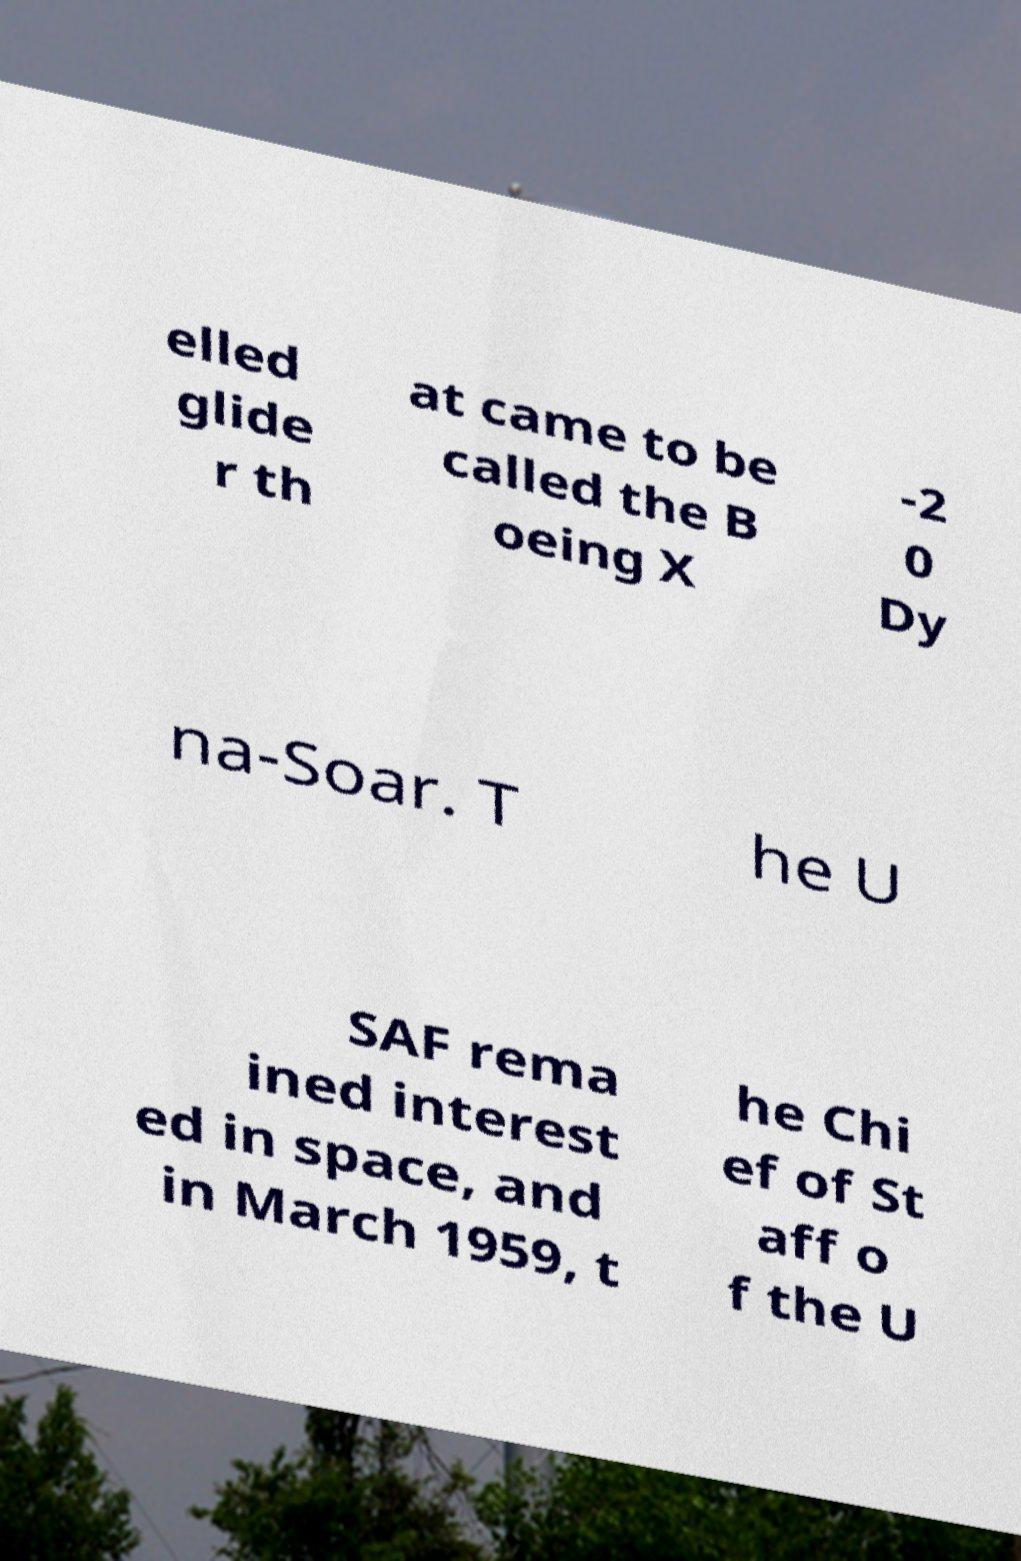Can you read and provide the text displayed in the image?This photo seems to have some interesting text. Can you extract and type it out for me? elled glide r th at came to be called the B oeing X -2 0 Dy na-Soar. T he U SAF rema ined interest ed in space, and in March 1959, t he Chi ef of St aff o f the U 